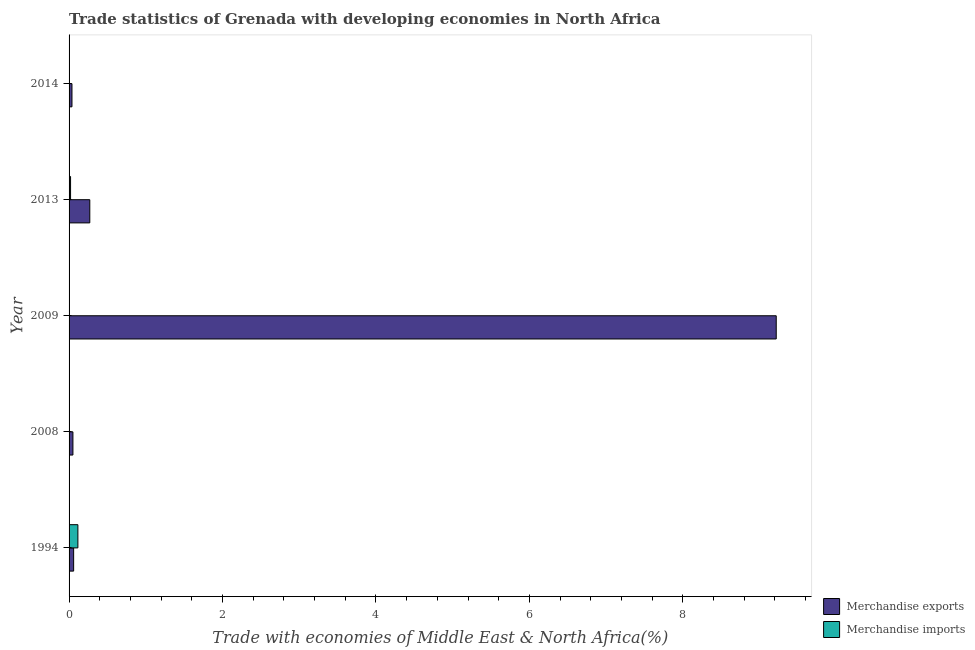How many different coloured bars are there?
Provide a short and direct response. 2. How many groups of bars are there?
Make the answer very short. 5. How many bars are there on the 2nd tick from the bottom?
Your answer should be very brief. 2. What is the label of the 3rd group of bars from the top?
Make the answer very short. 2009. What is the merchandise exports in 2013?
Keep it short and to the point. 0.27. Across all years, what is the maximum merchandise exports?
Make the answer very short. 9.22. Across all years, what is the minimum merchandise exports?
Offer a very short reply. 0.04. In which year was the merchandise imports maximum?
Your answer should be compact. 1994. What is the total merchandise exports in the graph?
Provide a short and direct response. 9.63. What is the difference between the merchandise exports in 2009 and that in 2014?
Offer a very short reply. 9.18. What is the difference between the merchandise imports in 2008 and the merchandise exports in 2013?
Your response must be concise. -0.27. What is the average merchandise exports per year?
Keep it short and to the point. 1.93. In the year 2009, what is the difference between the merchandise exports and merchandise imports?
Your response must be concise. 9.21. What is the ratio of the merchandise exports in 2008 to that in 2009?
Your answer should be compact. 0.01. Is the merchandise exports in 2008 less than that in 2009?
Your response must be concise. Yes. What is the difference between the highest and the second highest merchandise imports?
Offer a terse response. 0.1. What is the difference between the highest and the lowest merchandise imports?
Give a very brief answer. 0.11. How many bars are there?
Provide a succinct answer. 10. How many years are there in the graph?
Make the answer very short. 5. What is the difference between two consecutive major ticks on the X-axis?
Provide a succinct answer. 2. Are the values on the major ticks of X-axis written in scientific E-notation?
Your response must be concise. No. Does the graph contain any zero values?
Your answer should be very brief. No. Does the graph contain grids?
Offer a very short reply. No. How are the legend labels stacked?
Offer a terse response. Vertical. What is the title of the graph?
Provide a succinct answer. Trade statistics of Grenada with developing economies in North Africa. What is the label or title of the X-axis?
Offer a terse response. Trade with economies of Middle East & North Africa(%). What is the label or title of the Y-axis?
Offer a very short reply. Year. What is the Trade with economies of Middle East & North Africa(%) in Merchandise exports in 1994?
Your response must be concise. 0.06. What is the Trade with economies of Middle East & North Africa(%) of Merchandise imports in 1994?
Offer a very short reply. 0.11. What is the Trade with economies of Middle East & North Africa(%) of Merchandise exports in 2008?
Your response must be concise. 0.05. What is the Trade with economies of Middle East & North Africa(%) of Merchandise imports in 2008?
Provide a short and direct response. 0. What is the Trade with economies of Middle East & North Africa(%) in Merchandise exports in 2009?
Provide a short and direct response. 9.22. What is the Trade with economies of Middle East & North Africa(%) in Merchandise imports in 2009?
Make the answer very short. 0. What is the Trade with economies of Middle East & North Africa(%) of Merchandise exports in 2013?
Keep it short and to the point. 0.27. What is the Trade with economies of Middle East & North Africa(%) of Merchandise imports in 2013?
Your answer should be very brief. 0.02. What is the Trade with economies of Middle East & North Africa(%) in Merchandise exports in 2014?
Your answer should be very brief. 0.04. What is the Trade with economies of Middle East & North Africa(%) of Merchandise imports in 2014?
Provide a short and direct response. 0. Across all years, what is the maximum Trade with economies of Middle East & North Africa(%) of Merchandise exports?
Ensure brevity in your answer.  9.22. Across all years, what is the maximum Trade with economies of Middle East & North Africa(%) in Merchandise imports?
Provide a short and direct response. 0.11. Across all years, what is the minimum Trade with economies of Middle East & North Africa(%) of Merchandise exports?
Your answer should be very brief. 0.04. Across all years, what is the minimum Trade with economies of Middle East & North Africa(%) of Merchandise imports?
Offer a very short reply. 0. What is the total Trade with economies of Middle East & North Africa(%) of Merchandise exports in the graph?
Your response must be concise. 9.63. What is the total Trade with economies of Middle East & North Africa(%) of Merchandise imports in the graph?
Offer a very short reply. 0.14. What is the difference between the Trade with economies of Middle East & North Africa(%) in Merchandise exports in 1994 and that in 2008?
Give a very brief answer. 0.01. What is the difference between the Trade with economies of Middle East & North Africa(%) in Merchandise imports in 1994 and that in 2008?
Provide a short and direct response. 0.11. What is the difference between the Trade with economies of Middle East & North Africa(%) in Merchandise exports in 1994 and that in 2009?
Provide a succinct answer. -9.16. What is the difference between the Trade with economies of Middle East & North Africa(%) of Merchandise imports in 1994 and that in 2009?
Your answer should be compact. 0.11. What is the difference between the Trade with economies of Middle East & North Africa(%) of Merchandise exports in 1994 and that in 2013?
Give a very brief answer. -0.21. What is the difference between the Trade with economies of Middle East & North Africa(%) of Merchandise imports in 1994 and that in 2013?
Provide a succinct answer. 0.1. What is the difference between the Trade with economies of Middle East & North Africa(%) of Merchandise exports in 1994 and that in 2014?
Ensure brevity in your answer.  0.02. What is the difference between the Trade with economies of Middle East & North Africa(%) of Merchandise imports in 1994 and that in 2014?
Offer a terse response. 0.11. What is the difference between the Trade with economies of Middle East & North Africa(%) of Merchandise exports in 2008 and that in 2009?
Provide a succinct answer. -9.17. What is the difference between the Trade with economies of Middle East & North Africa(%) in Merchandise imports in 2008 and that in 2009?
Provide a short and direct response. -0. What is the difference between the Trade with economies of Middle East & North Africa(%) of Merchandise exports in 2008 and that in 2013?
Your answer should be very brief. -0.22. What is the difference between the Trade with economies of Middle East & North Africa(%) of Merchandise imports in 2008 and that in 2013?
Make the answer very short. -0.02. What is the difference between the Trade with economies of Middle East & North Africa(%) in Merchandise exports in 2008 and that in 2014?
Offer a very short reply. 0.01. What is the difference between the Trade with economies of Middle East & North Africa(%) in Merchandise imports in 2008 and that in 2014?
Your response must be concise. -0. What is the difference between the Trade with economies of Middle East & North Africa(%) of Merchandise exports in 2009 and that in 2013?
Provide a short and direct response. 8.95. What is the difference between the Trade with economies of Middle East & North Africa(%) in Merchandise imports in 2009 and that in 2013?
Your answer should be compact. -0.02. What is the difference between the Trade with economies of Middle East & North Africa(%) in Merchandise exports in 2009 and that in 2014?
Offer a very short reply. 9.18. What is the difference between the Trade with economies of Middle East & North Africa(%) in Merchandise exports in 2013 and that in 2014?
Your answer should be compact. 0.23. What is the difference between the Trade with economies of Middle East & North Africa(%) of Merchandise imports in 2013 and that in 2014?
Your answer should be very brief. 0.02. What is the difference between the Trade with economies of Middle East & North Africa(%) in Merchandise exports in 1994 and the Trade with economies of Middle East & North Africa(%) in Merchandise imports in 2008?
Your response must be concise. 0.06. What is the difference between the Trade with economies of Middle East & North Africa(%) of Merchandise exports in 1994 and the Trade with economies of Middle East & North Africa(%) of Merchandise imports in 2009?
Your response must be concise. 0.06. What is the difference between the Trade with economies of Middle East & North Africa(%) in Merchandise exports in 1994 and the Trade with economies of Middle East & North Africa(%) in Merchandise imports in 2013?
Offer a terse response. 0.04. What is the difference between the Trade with economies of Middle East & North Africa(%) in Merchandise exports in 1994 and the Trade with economies of Middle East & North Africa(%) in Merchandise imports in 2014?
Offer a very short reply. 0.06. What is the difference between the Trade with economies of Middle East & North Africa(%) in Merchandise exports in 2008 and the Trade with economies of Middle East & North Africa(%) in Merchandise imports in 2009?
Provide a short and direct response. 0.05. What is the difference between the Trade with economies of Middle East & North Africa(%) in Merchandise exports in 2008 and the Trade with economies of Middle East & North Africa(%) in Merchandise imports in 2013?
Offer a terse response. 0.03. What is the difference between the Trade with economies of Middle East & North Africa(%) in Merchandise exports in 2008 and the Trade with economies of Middle East & North Africa(%) in Merchandise imports in 2014?
Provide a succinct answer. 0.05. What is the difference between the Trade with economies of Middle East & North Africa(%) in Merchandise exports in 2009 and the Trade with economies of Middle East & North Africa(%) in Merchandise imports in 2013?
Provide a short and direct response. 9.2. What is the difference between the Trade with economies of Middle East & North Africa(%) of Merchandise exports in 2009 and the Trade with economies of Middle East & North Africa(%) of Merchandise imports in 2014?
Offer a very short reply. 9.21. What is the difference between the Trade with economies of Middle East & North Africa(%) of Merchandise exports in 2013 and the Trade with economies of Middle East & North Africa(%) of Merchandise imports in 2014?
Provide a short and direct response. 0.27. What is the average Trade with economies of Middle East & North Africa(%) in Merchandise exports per year?
Keep it short and to the point. 1.93. What is the average Trade with economies of Middle East & North Africa(%) in Merchandise imports per year?
Provide a short and direct response. 0.03. In the year 1994, what is the difference between the Trade with economies of Middle East & North Africa(%) of Merchandise exports and Trade with economies of Middle East & North Africa(%) of Merchandise imports?
Your response must be concise. -0.06. In the year 2008, what is the difference between the Trade with economies of Middle East & North Africa(%) in Merchandise exports and Trade with economies of Middle East & North Africa(%) in Merchandise imports?
Offer a terse response. 0.05. In the year 2009, what is the difference between the Trade with economies of Middle East & North Africa(%) of Merchandise exports and Trade with economies of Middle East & North Africa(%) of Merchandise imports?
Provide a succinct answer. 9.21. In the year 2013, what is the difference between the Trade with economies of Middle East & North Africa(%) of Merchandise exports and Trade with economies of Middle East & North Africa(%) of Merchandise imports?
Provide a succinct answer. 0.25. In the year 2014, what is the difference between the Trade with economies of Middle East & North Africa(%) of Merchandise exports and Trade with economies of Middle East & North Africa(%) of Merchandise imports?
Your response must be concise. 0.03. What is the ratio of the Trade with economies of Middle East & North Africa(%) of Merchandise exports in 1994 to that in 2008?
Give a very brief answer. 1.18. What is the ratio of the Trade with economies of Middle East & North Africa(%) in Merchandise imports in 1994 to that in 2008?
Your answer should be very brief. 259.97. What is the ratio of the Trade with economies of Middle East & North Africa(%) of Merchandise exports in 1994 to that in 2009?
Give a very brief answer. 0.01. What is the ratio of the Trade with economies of Middle East & North Africa(%) of Merchandise imports in 1994 to that in 2009?
Provide a succinct answer. 30.38. What is the ratio of the Trade with economies of Middle East & North Africa(%) in Merchandise exports in 1994 to that in 2013?
Make the answer very short. 0.22. What is the ratio of the Trade with economies of Middle East & North Africa(%) in Merchandise imports in 1994 to that in 2013?
Your answer should be very brief. 5.91. What is the ratio of the Trade with economies of Middle East & North Africa(%) of Merchandise exports in 1994 to that in 2014?
Offer a very short reply. 1.57. What is the ratio of the Trade with economies of Middle East & North Africa(%) of Merchandise imports in 1994 to that in 2014?
Provide a short and direct response. 31.57. What is the ratio of the Trade with economies of Middle East & North Africa(%) of Merchandise exports in 2008 to that in 2009?
Provide a succinct answer. 0.01. What is the ratio of the Trade with economies of Middle East & North Africa(%) in Merchandise imports in 2008 to that in 2009?
Make the answer very short. 0.12. What is the ratio of the Trade with economies of Middle East & North Africa(%) in Merchandise exports in 2008 to that in 2013?
Provide a succinct answer. 0.19. What is the ratio of the Trade with economies of Middle East & North Africa(%) in Merchandise imports in 2008 to that in 2013?
Provide a succinct answer. 0.02. What is the ratio of the Trade with economies of Middle East & North Africa(%) in Merchandise exports in 2008 to that in 2014?
Offer a very short reply. 1.33. What is the ratio of the Trade with economies of Middle East & North Africa(%) in Merchandise imports in 2008 to that in 2014?
Your response must be concise. 0.12. What is the ratio of the Trade with economies of Middle East & North Africa(%) in Merchandise exports in 2009 to that in 2013?
Give a very brief answer. 34.11. What is the ratio of the Trade with economies of Middle East & North Africa(%) in Merchandise imports in 2009 to that in 2013?
Your answer should be compact. 0.19. What is the ratio of the Trade with economies of Middle East & North Africa(%) of Merchandise exports in 2009 to that in 2014?
Offer a terse response. 243.92. What is the ratio of the Trade with economies of Middle East & North Africa(%) in Merchandise imports in 2009 to that in 2014?
Offer a terse response. 1.04. What is the ratio of the Trade with economies of Middle East & North Africa(%) in Merchandise exports in 2013 to that in 2014?
Your answer should be compact. 7.15. What is the ratio of the Trade with economies of Middle East & North Africa(%) in Merchandise imports in 2013 to that in 2014?
Your answer should be compact. 5.34. What is the difference between the highest and the second highest Trade with economies of Middle East & North Africa(%) in Merchandise exports?
Give a very brief answer. 8.95. What is the difference between the highest and the second highest Trade with economies of Middle East & North Africa(%) of Merchandise imports?
Your answer should be very brief. 0.1. What is the difference between the highest and the lowest Trade with economies of Middle East & North Africa(%) in Merchandise exports?
Offer a very short reply. 9.18. What is the difference between the highest and the lowest Trade with economies of Middle East & North Africa(%) of Merchandise imports?
Ensure brevity in your answer.  0.11. 